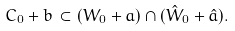<formula> <loc_0><loc_0><loc_500><loc_500>C _ { 0 } + b \, \subset ( W _ { 0 } + a ) \cap ( \hat { W } _ { 0 } + \hat { a } ) .</formula> 